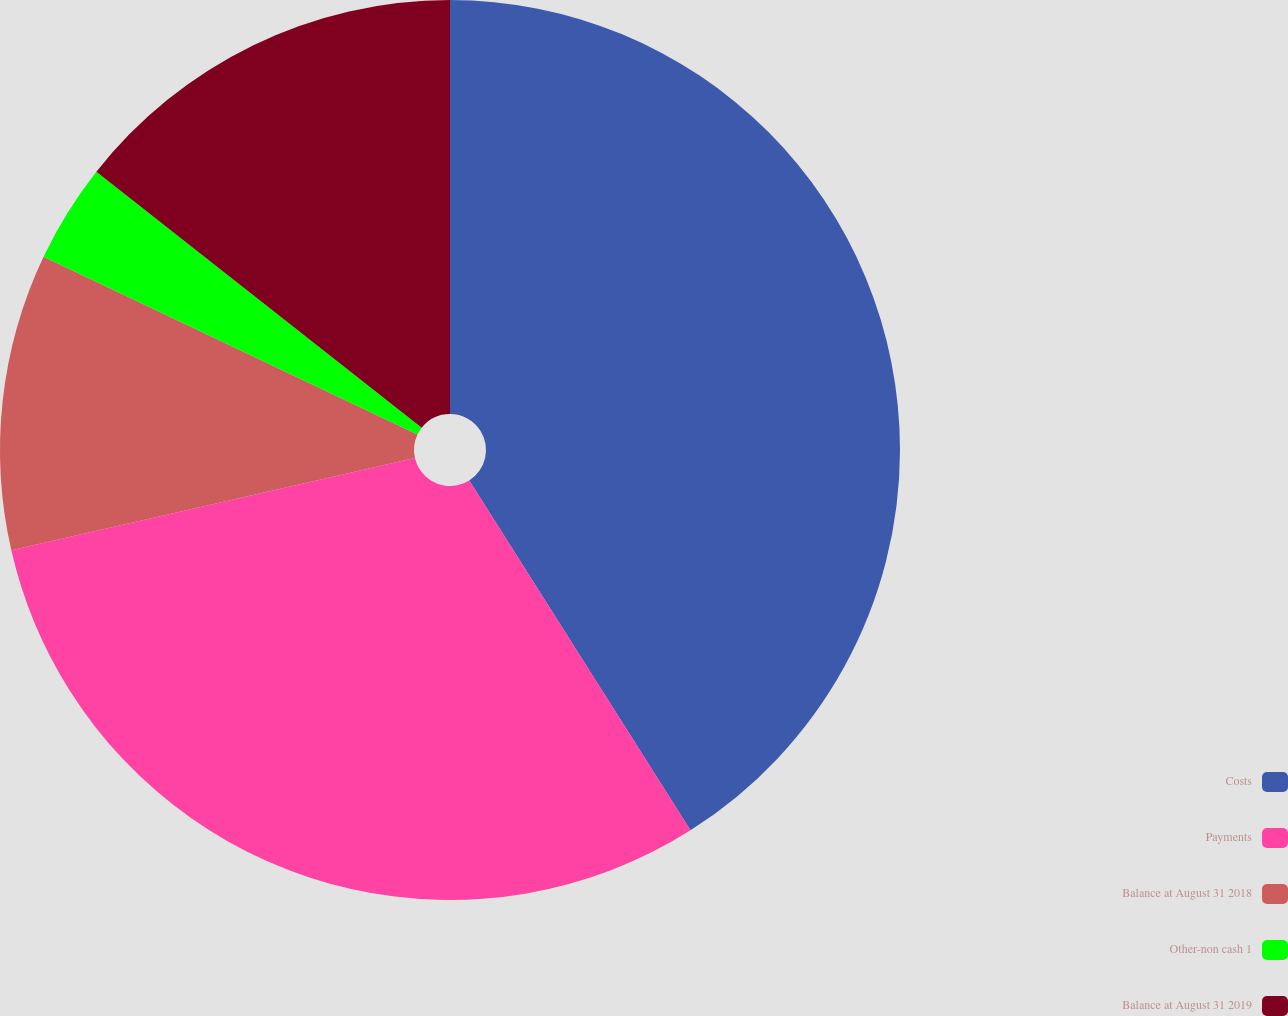<chart> <loc_0><loc_0><loc_500><loc_500><pie_chart><fcel>Costs<fcel>Payments<fcel>Balance at August 31 2018<fcel>Other-non cash 1<fcel>Balance at August 31 2019<nl><fcel>41.03%<fcel>30.4%<fcel>10.64%<fcel>3.55%<fcel>14.39%<nl></chart> 